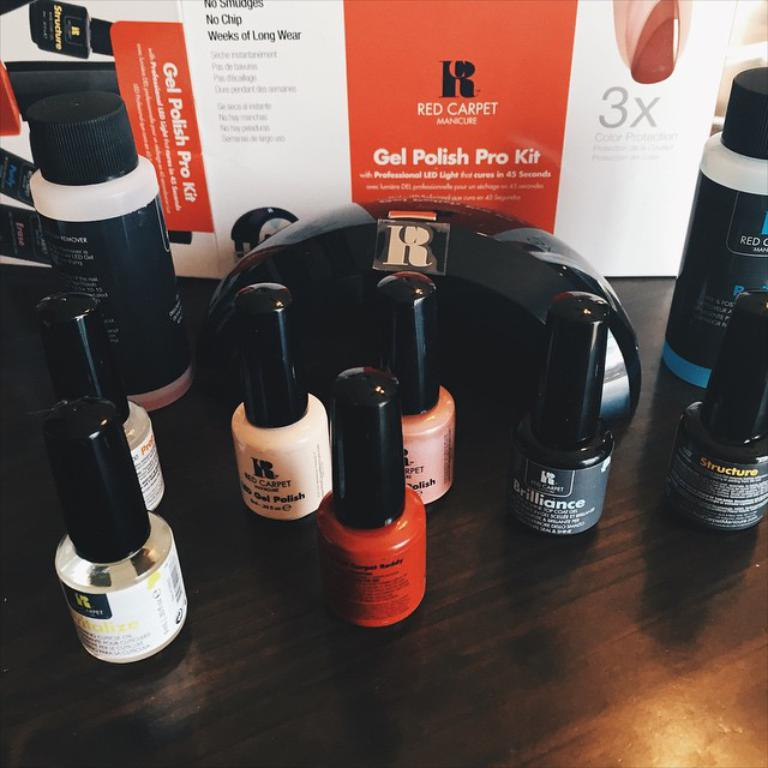<image>
Present a compact description of the photo's key features. the words gel polish pro kit are on an item 